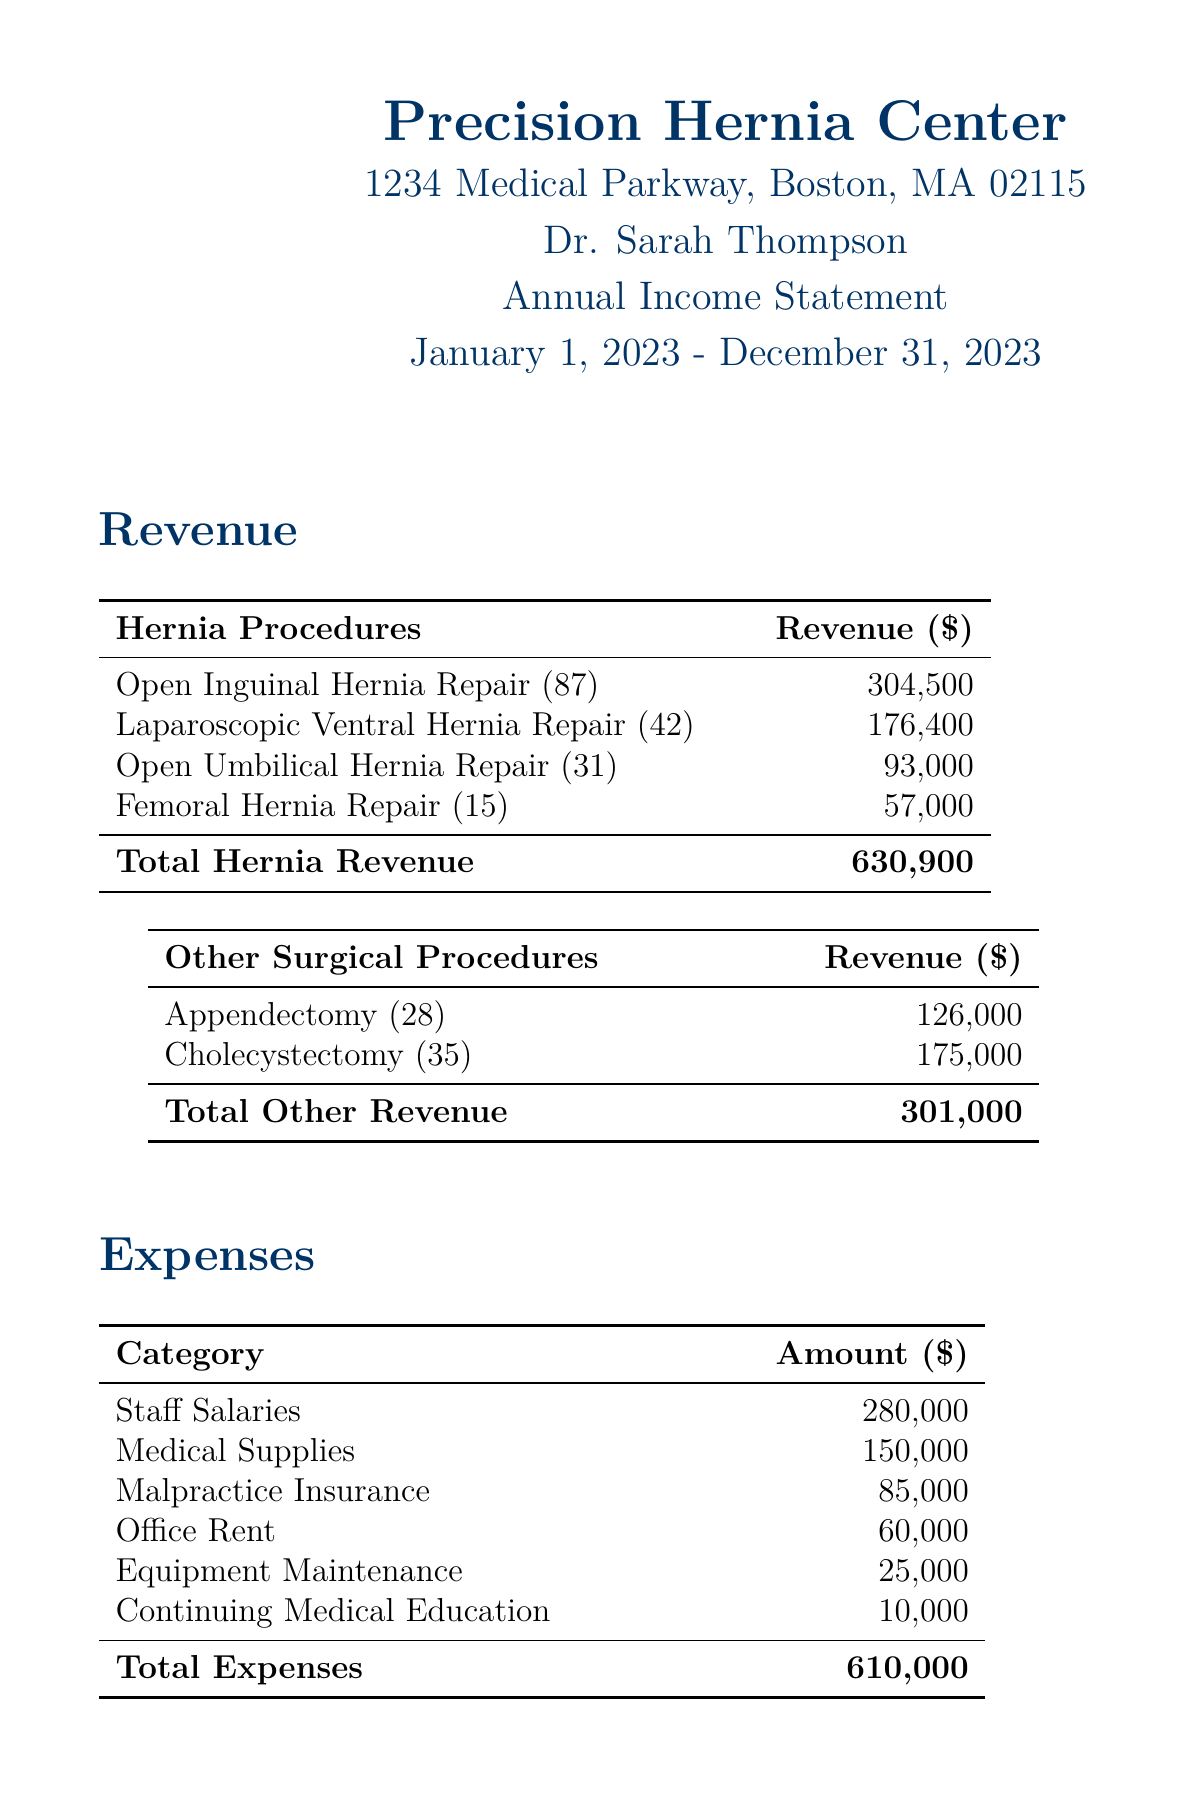what is the name of the practice? The name of the practice is presented at the top of the document.
Answer: Precision Hernia Center who is the operating physician? The operating physician is mentioned in the practice details section.
Answer: Dr. Sarah Thompson what is the total revenue from hernia procedures? The total revenue from hernia procedures is summed up in the revenue section of the document.
Answer: 630900 how many Open Inguinal Hernia Repairs were performed? The count of Open Inguinal Hernia Repairs is specified in the procedures list.
Answer: 87 what percentage of total revenue is from hernia procedures? The document notes that hernia procedures account for a specific percentage of total revenue.
Answer: 67.7% what were the total expenses? Total expenses are provided in the financial summary of the document.
Answer: 610000 which hernia procedure has the highest revenue? The procedure with the highest revenue is identified in the revenue breakdown for hernia procedures.
Answer: Open Inguinal Hernia Repair what is the net income for the reporting period? Net income is highlighted in the financial summary section of the document.
Answer: 321900 how much was spent on medical supplies? The amount spent on medical supplies is listed under the expenses category.
Answer: 150000 